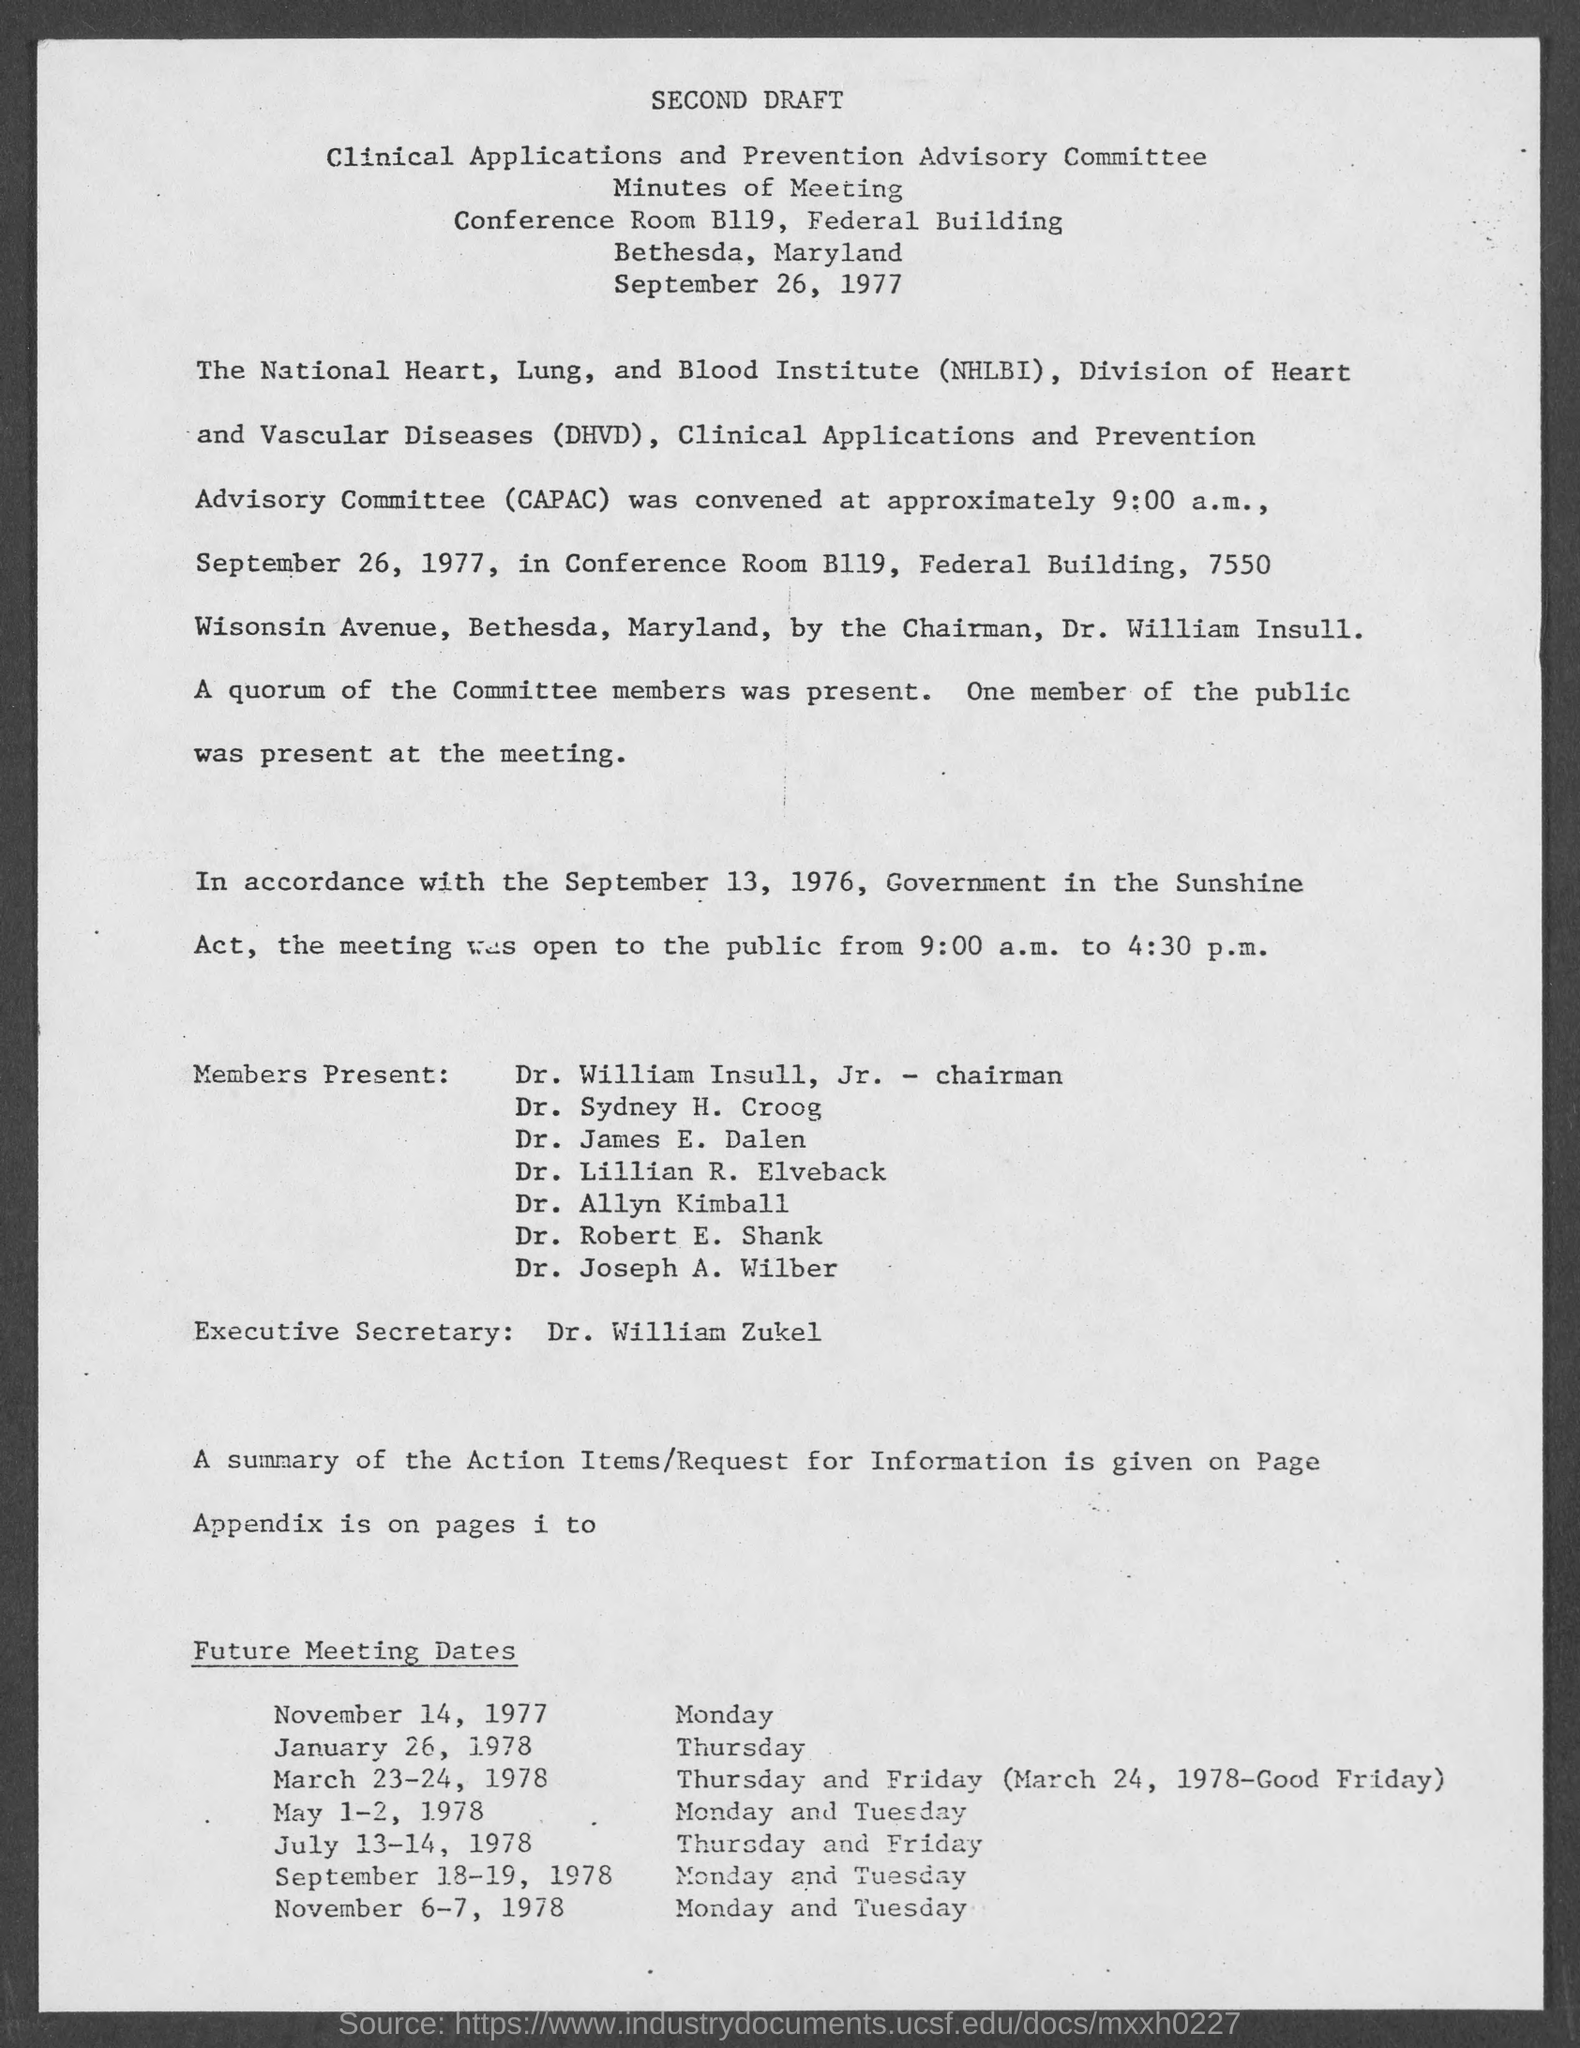What is the Title of the document?
Your answer should be compact. Second draft. 